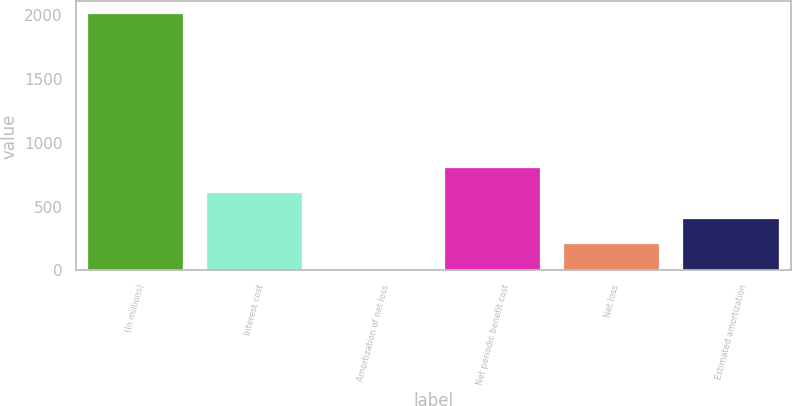Convert chart to OTSL. <chart><loc_0><loc_0><loc_500><loc_500><bar_chart><fcel>(In millions)<fcel>Interest cost<fcel>Amortization of net loss<fcel>Net periodic benefit cost<fcel>Net loss<fcel>Estimated amortization<nl><fcel>2010<fcel>604.4<fcel>2<fcel>805.2<fcel>202.8<fcel>403.6<nl></chart> 